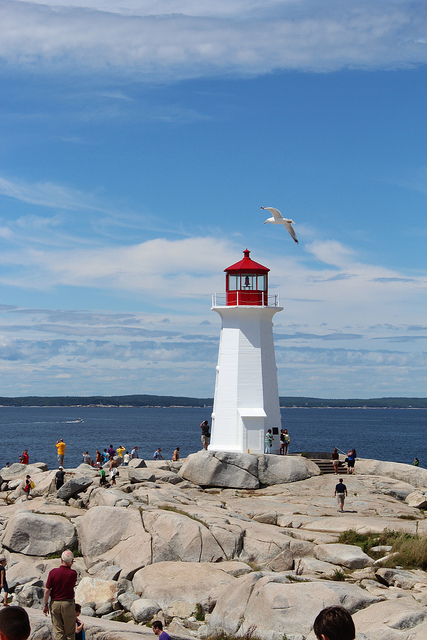Are there any animals in the scene? Yes, there is a seagull flying in the sky to the left of the lighthouse, which adds a dynamic element to the serene coastal scene. 